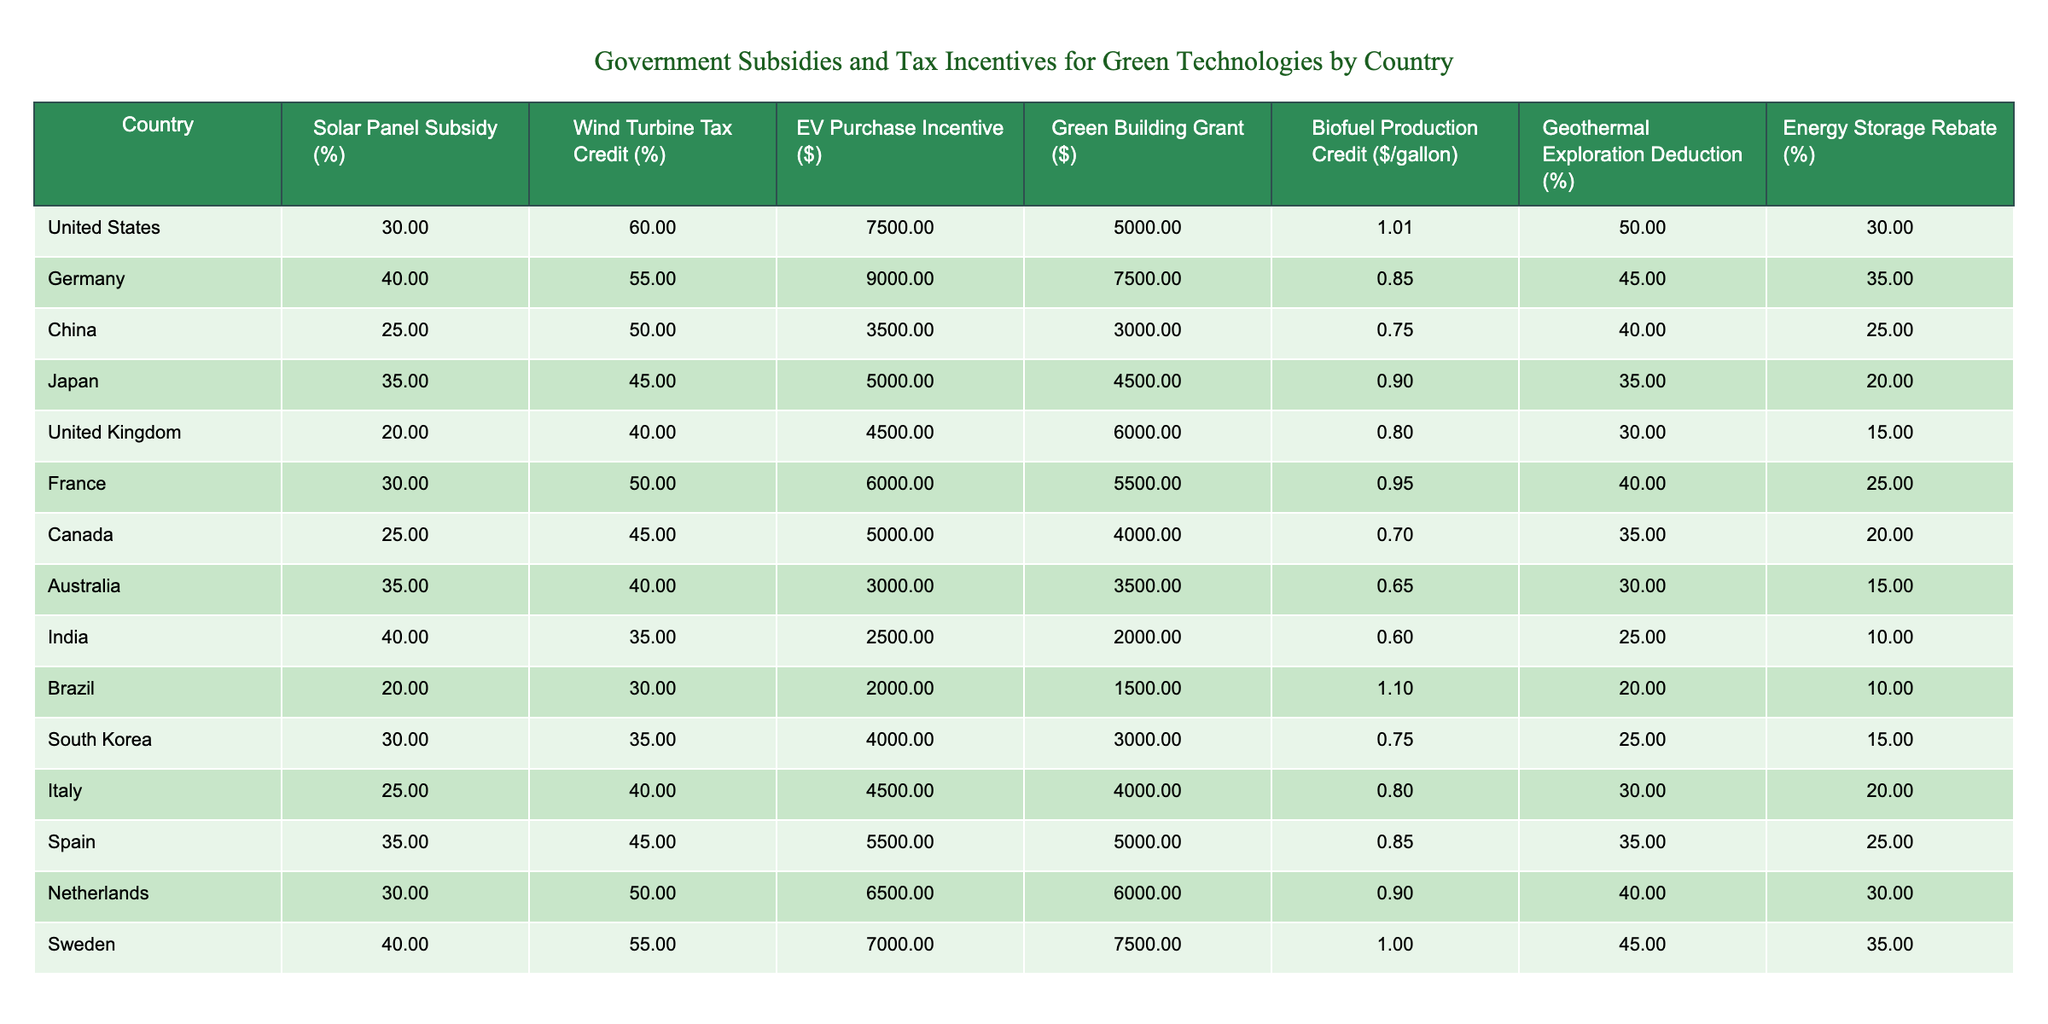What country offers the highest subsidy for solar panels? By looking at the table, Germany has the highest subsidy rate for solar panels at 40%.
Answer: Germany What is the EV purchase incentive in Japan? The table states that the EV purchase incentive in Japan is $5,000.
Answer: $5,000 Which country provides a geothermal exploration deduction above 50%? The table shows that both the United States and Sweden provide a geothermal exploration deduction of 50% or more (50% in the US and 55% in Sweden).
Answer: Yes What is the average wind turbine tax credit among the countries listed? To calculate the average, we sum the tax credits for each country: (60 + 55 + 50 + 45 + 40 + 50 + 45 + 40 + 35 + 30 + 35 + 40 + 45 + 55) = 640. There are 14 countries, so the average is 640/14 ≈ 45.71.
Answer: Approximately 45.71% Which country has the lowest biofuel production credit per gallon? The table shows that India has the lowest biofuel production credit at $0.60 per gallon.
Answer: India Which country has both the highest solar panel subsidy and wind turbine tax credit? Germany has the highest solar panel subsidy at 40% and the second-highest wind turbine tax credit at 55%. The US has the highest wind turbine tax credit at 60% but a lower solar panel subsidy at 30%. Therefore, Germany has the highest combined value.
Answer: Germany What is the difference in energy storage rebate between the United States and Brazil? The energy storage rebate in the United States is 30%, while in Brazil it is 10%. The difference is 30% - 10% = 20%.
Answer: 20% Is there a country that offers no EV purchase incentive? The table indicates that Brazil offers an EV purchase incentive of $2,000, which is the lowest, but there are no entries of zero incentives. Therefore, the answer is no; all listed countries offer some EV purchase incentive.
Answer: No What is the total amount of incentives available for solar panels and wind turbines in Australia? The solar panel subsidy in Australia is 35%, and the wind turbine tax credit is 40%. Adding those two values gives 35% + 40% = 75%.
Answer: 75% What country has the highest total financial incentive when combining all subsidies and credits listed? To find the total, we add all the incentives for each country. Sweden has the highest combined amount: 40 + 55 + 7000 + 7500 + 1.00 + 45 + 35 = 16,675. Other countries do not surpass this total.
Answer: Sweden 